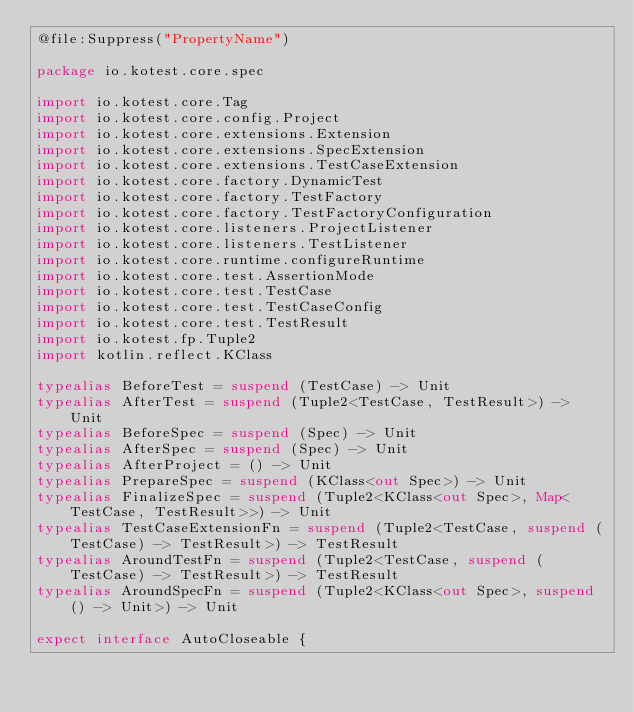Convert code to text. <code><loc_0><loc_0><loc_500><loc_500><_Kotlin_>@file:Suppress("PropertyName")

package io.kotest.core.spec

import io.kotest.core.Tag
import io.kotest.core.config.Project
import io.kotest.core.extensions.Extension
import io.kotest.core.extensions.SpecExtension
import io.kotest.core.extensions.TestCaseExtension
import io.kotest.core.factory.DynamicTest
import io.kotest.core.factory.TestFactory
import io.kotest.core.factory.TestFactoryConfiguration
import io.kotest.core.listeners.ProjectListener
import io.kotest.core.listeners.TestListener
import io.kotest.core.runtime.configureRuntime
import io.kotest.core.test.AssertionMode
import io.kotest.core.test.TestCase
import io.kotest.core.test.TestCaseConfig
import io.kotest.core.test.TestResult
import io.kotest.fp.Tuple2
import kotlin.reflect.KClass

typealias BeforeTest = suspend (TestCase) -> Unit
typealias AfterTest = suspend (Tuple2<TestCase, TestResult>) -> Unit
typealias BeforeSpec = suspend (Spec) -> Unit
typealias AfterSpec = suspend (Spec) -> Unit
typealias AfterProject = () -> Unit
typealias PrepareSpec = suspend (KClass<out Spec>) -> Unit
typealias FinalizeSpec = suspend (Tuple2<KClass<out Spec>, Map<TestCase, TestResult>>) -> Unit
typealias TestCaseExtensionFn = suspend (Tuple2<TestCase, suspend (TestCase) -> TestResult>) -> TestResult
typealias AroundTestFn = suspend (Tuple2<TestCase, suspend (TestCase) -> TestResult>) -> TestResult
typealias AroundSpecFn = suspend (Tuple2<KClass<out Spec>, suspend () -> Unit>) -> Unit

expect interface AutoCloseable {</code> 